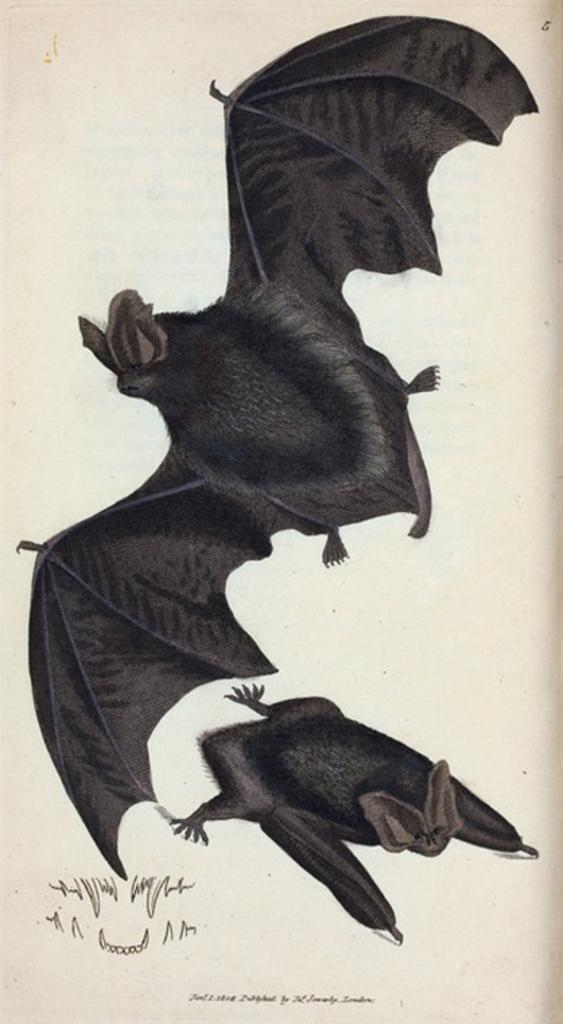What animals are present in the image? There are bats in the image. What else can be seen in the image besides the bats? There is text on a page in the image. What type of stew is being prepared in the image? There is no stew present in the image; it features bats and text on a page. What color is the ball in the image? There is no ball present in the image. 